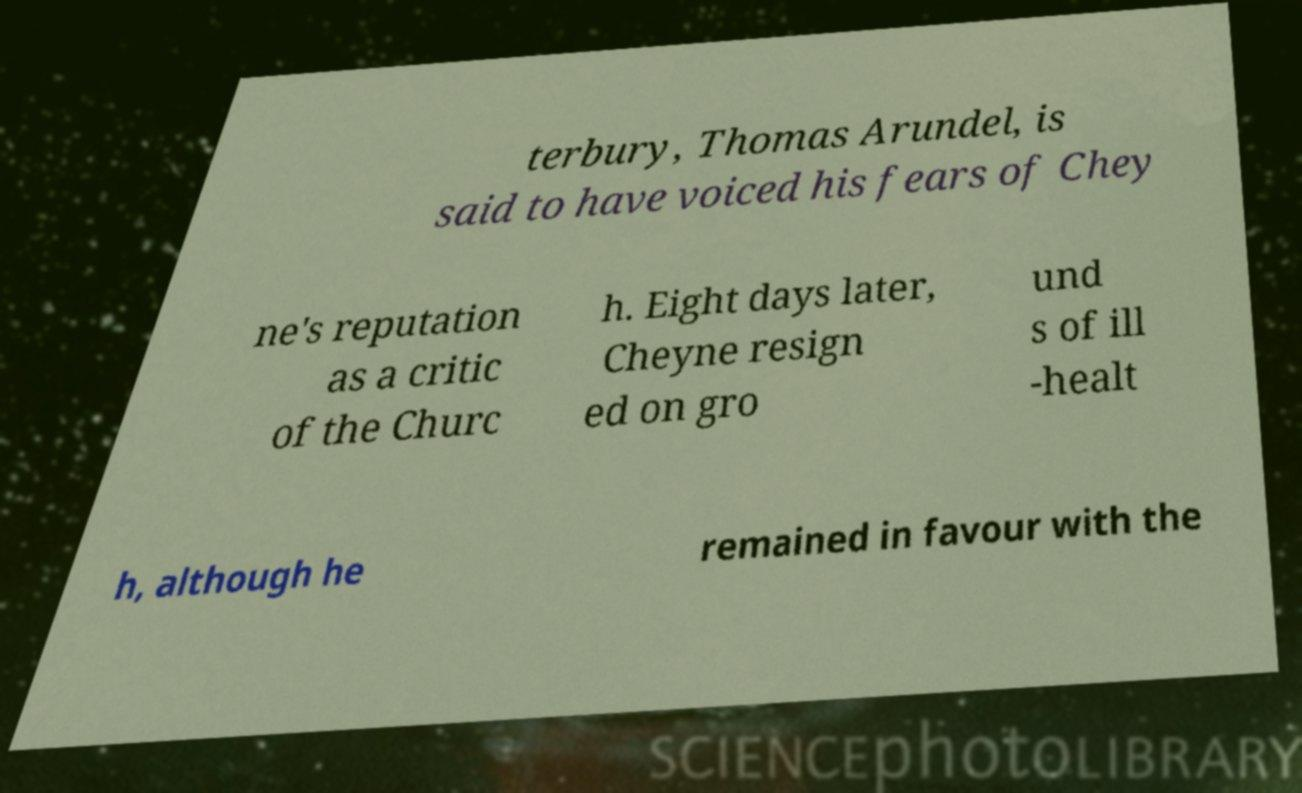Can you read and provide the text displayed in the image?This photo seems to have some interesting text. Can you extract and type it out for me? terbury, Thomas Arundel, is said to have voiced his fears of Chey ne's reputation as a critic of the Churc h. Eight days later, Cheyne resign ed on gro und s of ill -healt h, although he remained in favour with the 